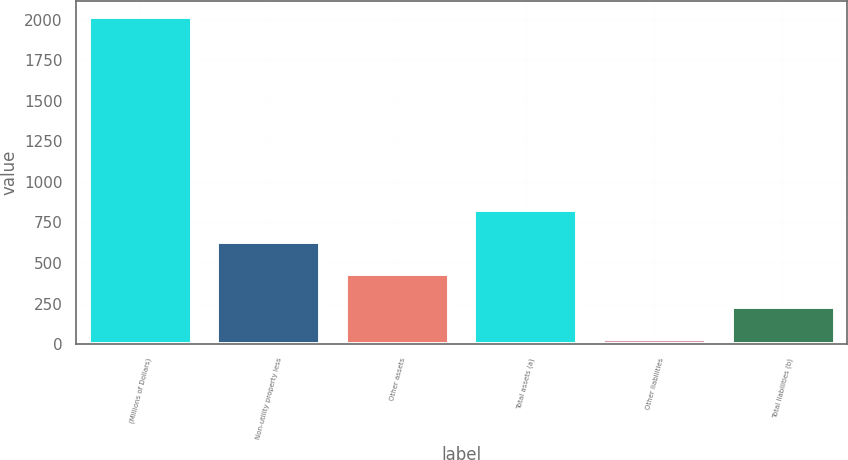Convert chart. <chart><loc_0><loc_0><loc_500><loc_500><bar_chart><fcel>(Millions of Dollars)<fcel>Non-utility property less<fcel>Other assets<fcel>Total assets (a)<fcel>Other liabilities<fcel>Total liabilities (b)<nl><fcel>2018<fcel>628.5<fcel>430<fcel>827<fcel>33<fcel>231.5<nl></chart> 